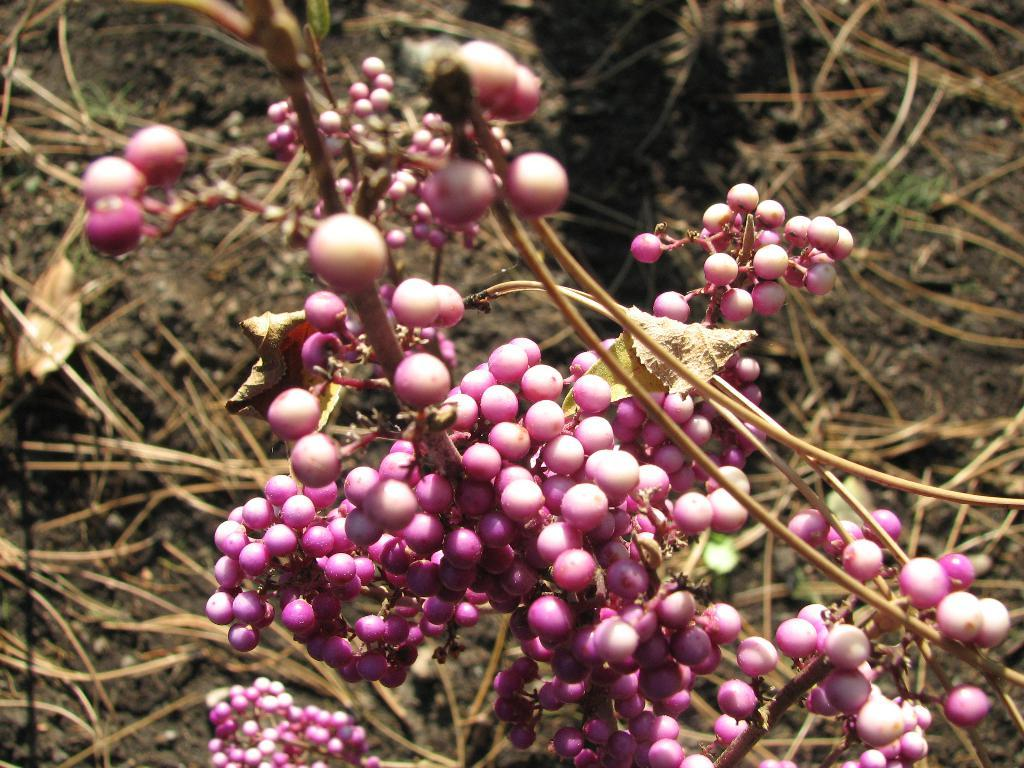What type of plant is depicted in the image? The image shows fruits of a plant, but it does not specify which plant. Can you describe the fruits in the image? The fruits of the plant are visible in the image, but their specific characteristics are not mentioned. Are there any other elements in the image besides the fruits? The facts provided only mention the fruits of the plant, so there is no information about any other elements in the image. What type of party is being held in the image? There is no party depicted in the image; it only shows fruits of a plant. Is the image framed in a specific style or material? The facts provided do not mention any information about the image's frame or presentation. 